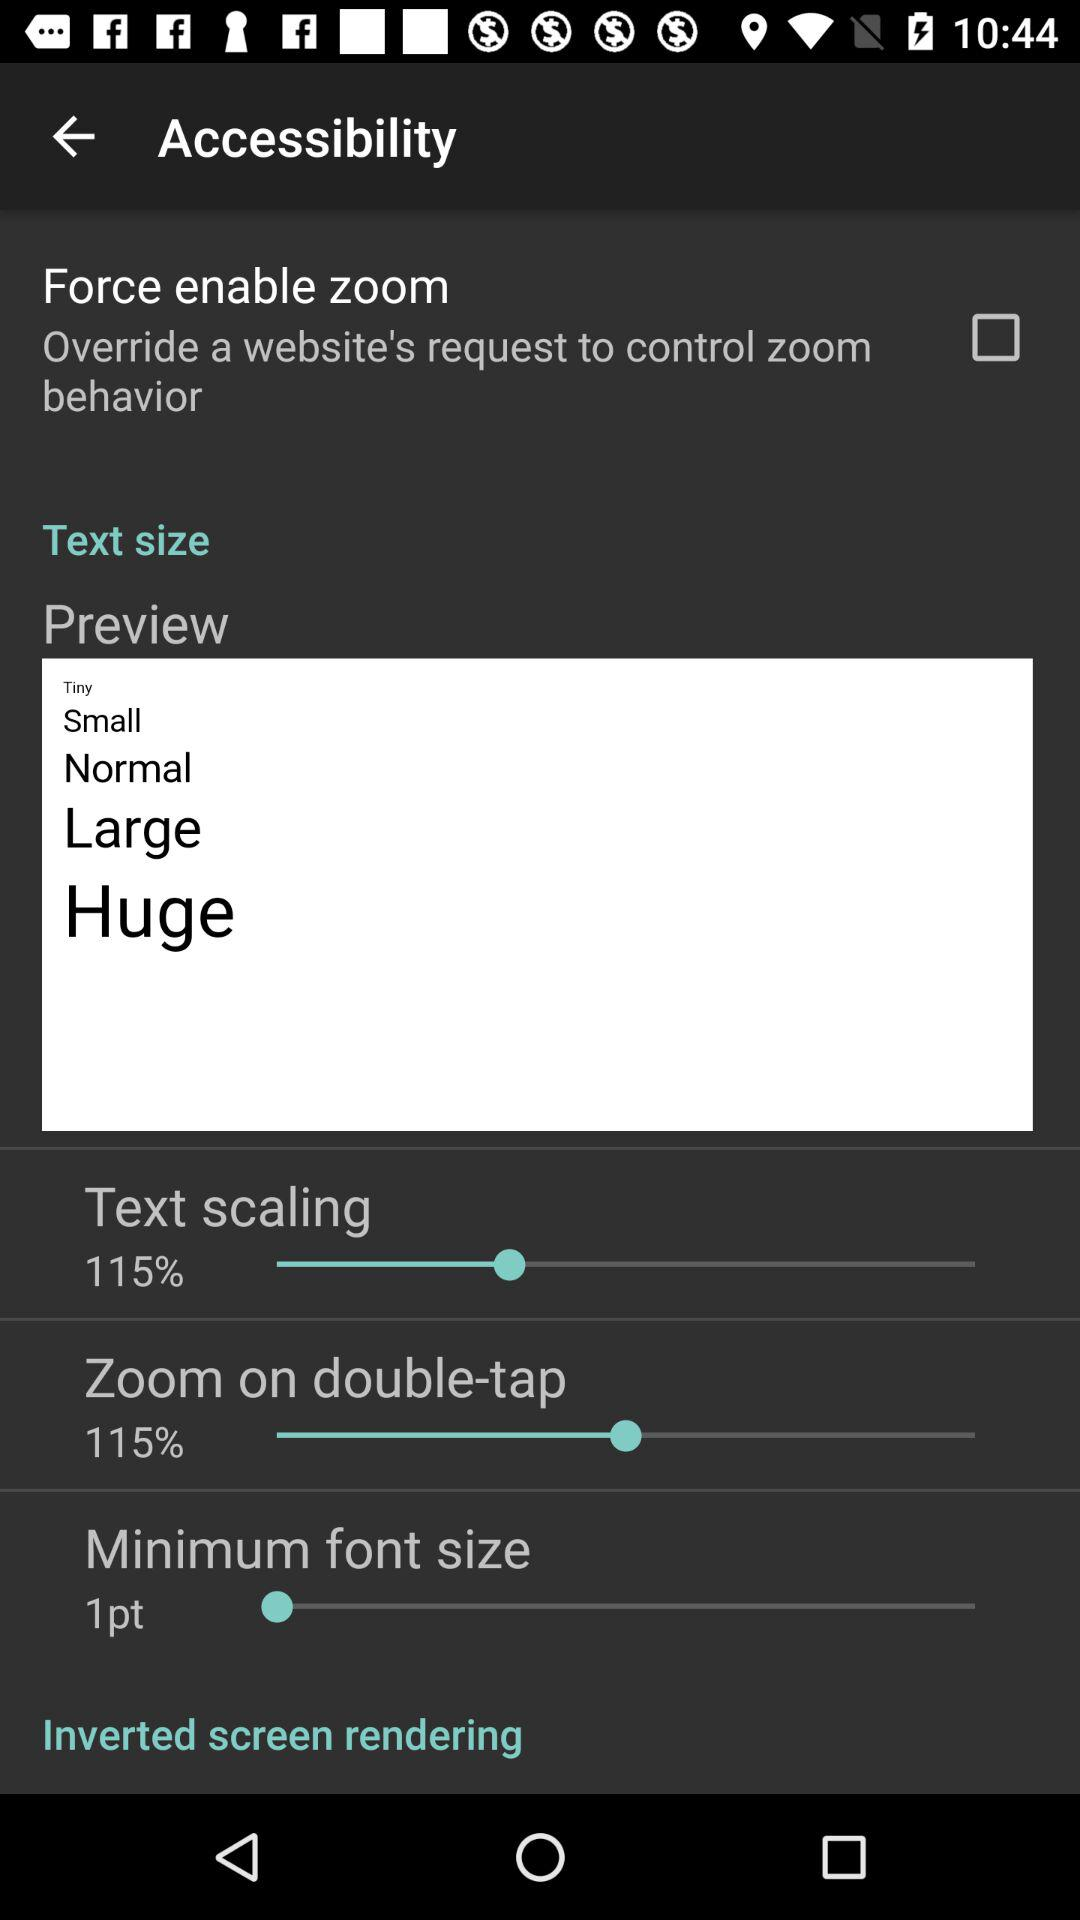What is the set minimum font size? The set minimum font size is 1pt. 